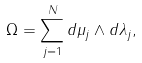<formula> <loc_0><loc_0><loc_500><loc_500>\Omega = \sum _ { j = 1 } ^ { N } d \mu _ { j } \wedge d \lambda _ { j } ,</formula> 